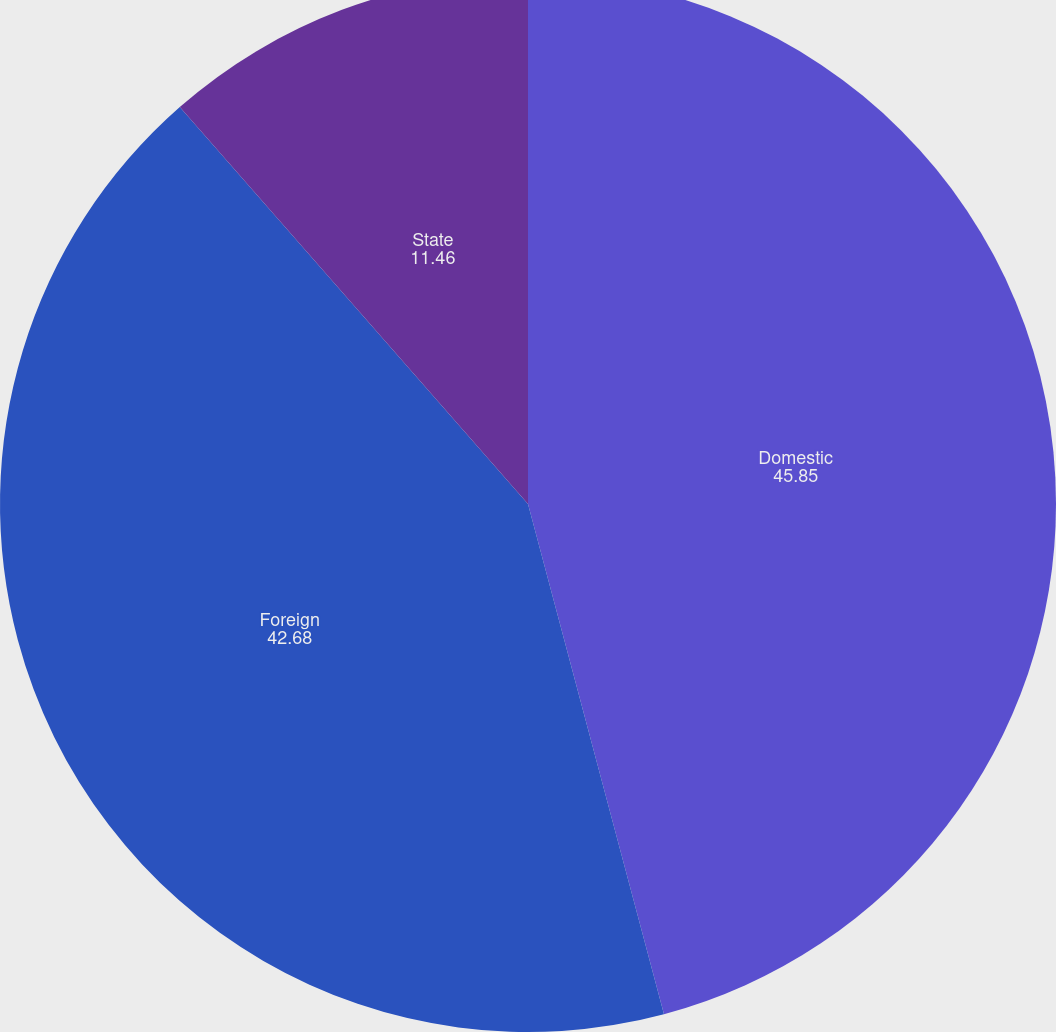Convert chart. <chart><loc_0><loc_0><loc_500><loc_500><pie_chart><fcel>Domestic<fcel>Foreign<fcel>State<nl><fcel>45.85%<fcel>42.68%<fcel>11.46%<nl></chart> 